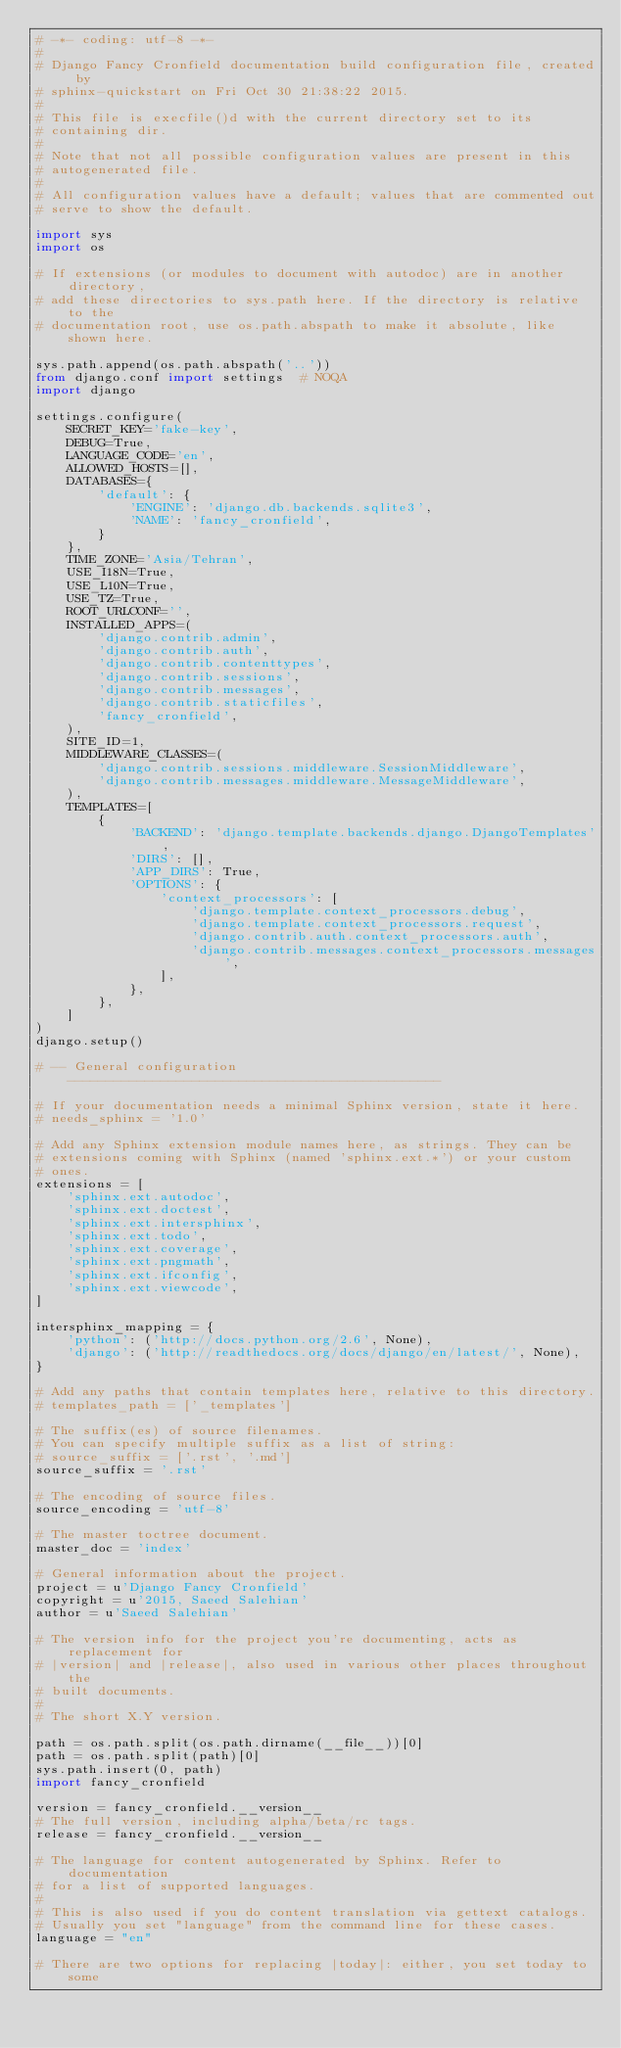Convert code to text. <code><loc_0><loc_0><loc_500><loc_500><_Python_># -*- coding: utf-8 -*-
#
# Django Fancy Cronfield documentation build configuration file, created by
# sphinx-quickstart on Fri Oct 30 21:38:22 2015.
#
# This file is execfile()d with the current directory set to its
# containing dir.
#
# Note that not all possible configuration values are present in this
# autogenerated file.
#
# All configuration values have a default; values that are commented out
# serve to show the default.

import sys
import os

# If extensions (or modules to document with autodoc) are in another directory,
# add these directories to sys.path here. If the directory is relative to the
# documentation root, use os.path.abspath to make it absolute, like shown here.

sys.path.append(os.path.abspath('..'))
from django.conf import settings  # NOQA
import django

settings.configure(
    SECRET_KEY='fake-key',
    DEBUG=True,
    LANGUAGE_CODE='en',
    ALLOWED_HOSTS=[],
    DATABASES={
        'default': {
            'ENGINE': 'django.db.backends.sqlite3',
            'NAME': 'fancy_cronfield',
        }
    },
    TIME_ZONE='Asia/Tehran',
    USE_I18N=True,
    USE_L10N=True,
    USE_TZ=True,
    ROOT_URLCONF='',
    INSTALLED_APPS=(
        'django.contrib.admin',
        'django.contrib.auth',
        'django.contrib.contenttypes',
        'django.contrib.sessions',
        'django.contrib.messages',
        'django.contrib.staticfiles',
        'fancy_cronfield',
    ),
    SITE_ID=1,
    MIDDLEWARE_CLASSES=(
        'django.contrib.sessions.middleware.SessionMiddleware',
        'django.contrib.messages.middleware.MessageMiddleware',
    ),
    TEMPLATES=[
        {
            'BACKEND': 'django.template.backends.django.DjangoTemplates',
            'DIRS': [],
            'APP_DIRS': True,
            'OPTIONS': {
                'context_processors': [
                    'django.template.context_processors.debug',
                    'django.template.context_processors.request',
                    'django.contrib.auth.context_processors.auth',
                    'django.contrib.messages.context_processors.messages',
                ],
            },
        },
    ]
)
django.setup()

# -- General configuration ------------------------------------------------

# If your documentation needs a minimal Sphinx version, state it here.
# needs_sphinx = '1.0'

# Add any Sphinx extension module names here, as strings. They can be
# extensions coming with Sphinx (named 'sphinx.ext.*') or your custom
# ones.
extensions = [
    'sphinx.ext.autodoc',
    'sphinx.ext.doctest',
    'sphinx.ext.intersphinx',
    'sphinx.ext.todo',
    'sphinx.ext.coverage',
    'sphinx.ext.pngmath',
    'sphinx.ext.ifconfig',
    'sphinx.ext.viewcode',
]

intersphinx_mapping = {
    'python': ('http://docs.python.org/2.6', None),
    'django': ('http://readthedocs.org/docs/django/en/latest/', None),
}

# Add any paths that contain templates here, relative to this directory.
# templates_path = ['_templates']

# The suffix(es) of source filenames.
# You can specify multiple suffix as a list of string:
# source_suffix = ['.rst', '.md']
source_suffix = '.rst'

# The encoding of source files.
source_encoding = 'utf-8'

# The master toctree document.
master_doc = 'index'

# General information about the project.
project = u'Django Fancy Cronfield'
copyright = u'2015, Saeed Salehian'
author = u'Saeed Salehian'

# The version info for the project you're documenting, acts as replacement for
# |version| and |release|, also used in various other places throughout the
# built documents.
#
# The short X.Y version.

path = os.path.split(os.path.dirname(__file__))[0]
path = os.path.split(path)[0]
sys.path.insert(0, path)
import fancy_cronfield

version = fancy_cronfield.__version__
# The full version, including alpha/beta/rc tags.
release = fancy_cronfield.__version__

# The language for content autogenerated by Sphinx. Refer to documentation
# for a list of supported languages.
#
# This is also used if you do content translation via gettext catalogs.
# Usually you set "language" from the command line for these cases.
language = "en"

# There are two options for replacing |today|: either, you set today to some</code> 